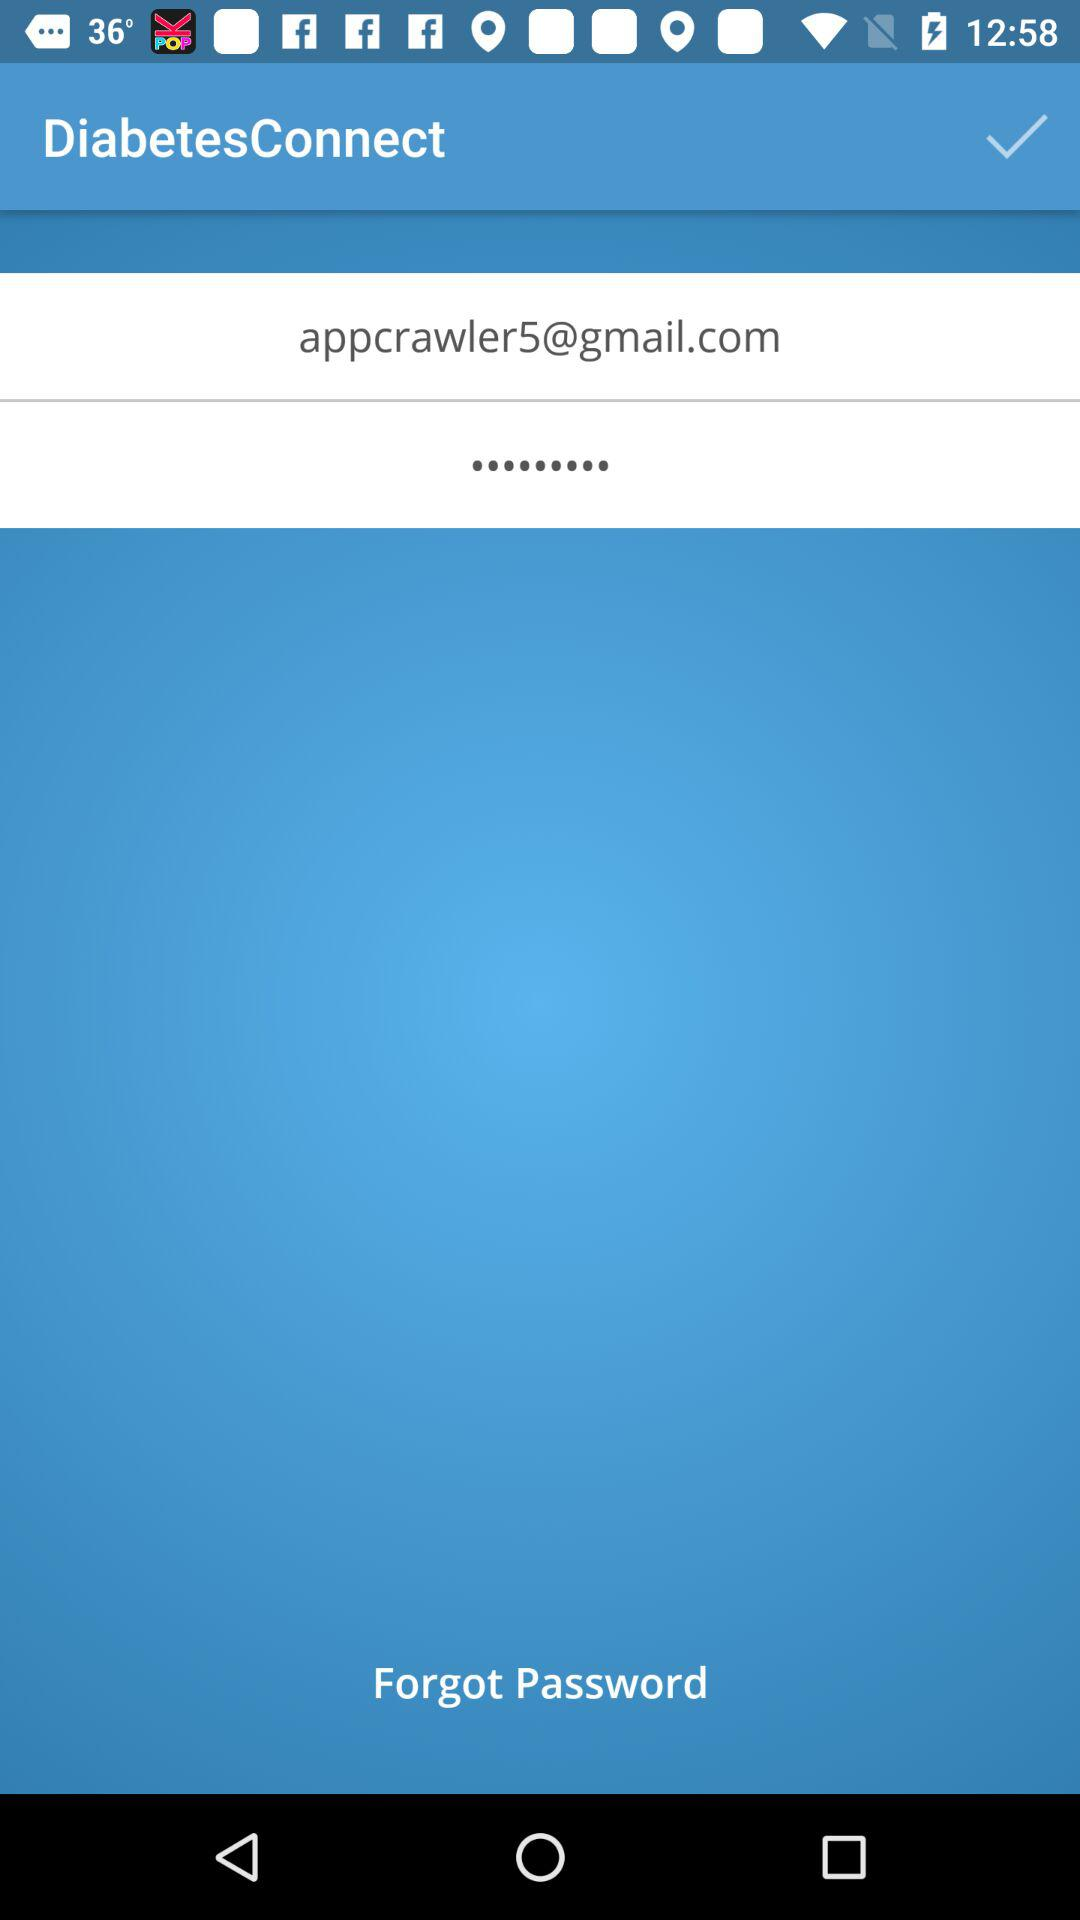What is the email address? The email address is appcrawler5@gmail.com. 